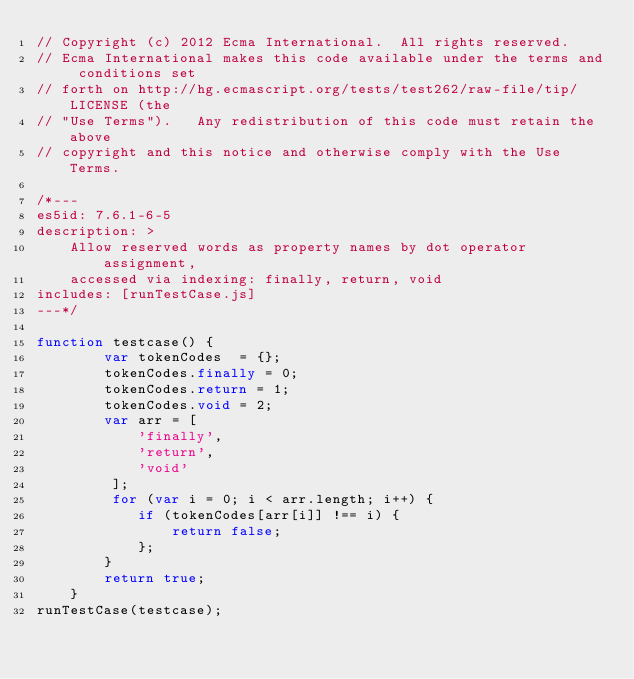Convert code to text. <code><loc_0><loc_0><loc_500><loc_500><_JavaScript_>// Copyright (c) 2012 Ecma International.  All rights reserved.
// Ecma International makes this code available under the terms and conditions set
// forth on http://hg.ecmascript.org/tests/test262/raw-file/tip/LICENSE (the
// "Use Terms").   Any redistribution of this code must retain the above
// copyright and this notice and otherwise comply with the Use Terms.

/*---
es5id: 7.6.1-6-5
description: >
    Allow reserved words as property names by dot operator assignment,
    accessed via indexing: finally, return, void
includes: [runTestCase.js]
---*/

function testcase() {
        var tokenCodes  = {};
        tokenCodes.finally = 0;
        tokenCodes.return = 1;
        tokenCodes.void = 2;
        var arr = [
            'finally', 
            'return', 
            'void'
         ];
         for (var i = 0; i < arr.length; i++) {
            if (tokenCodes[arr[i]] !== i) {
                return false;
            };
        }
        return true;
    }
runTestCase(testcase);
</code> 